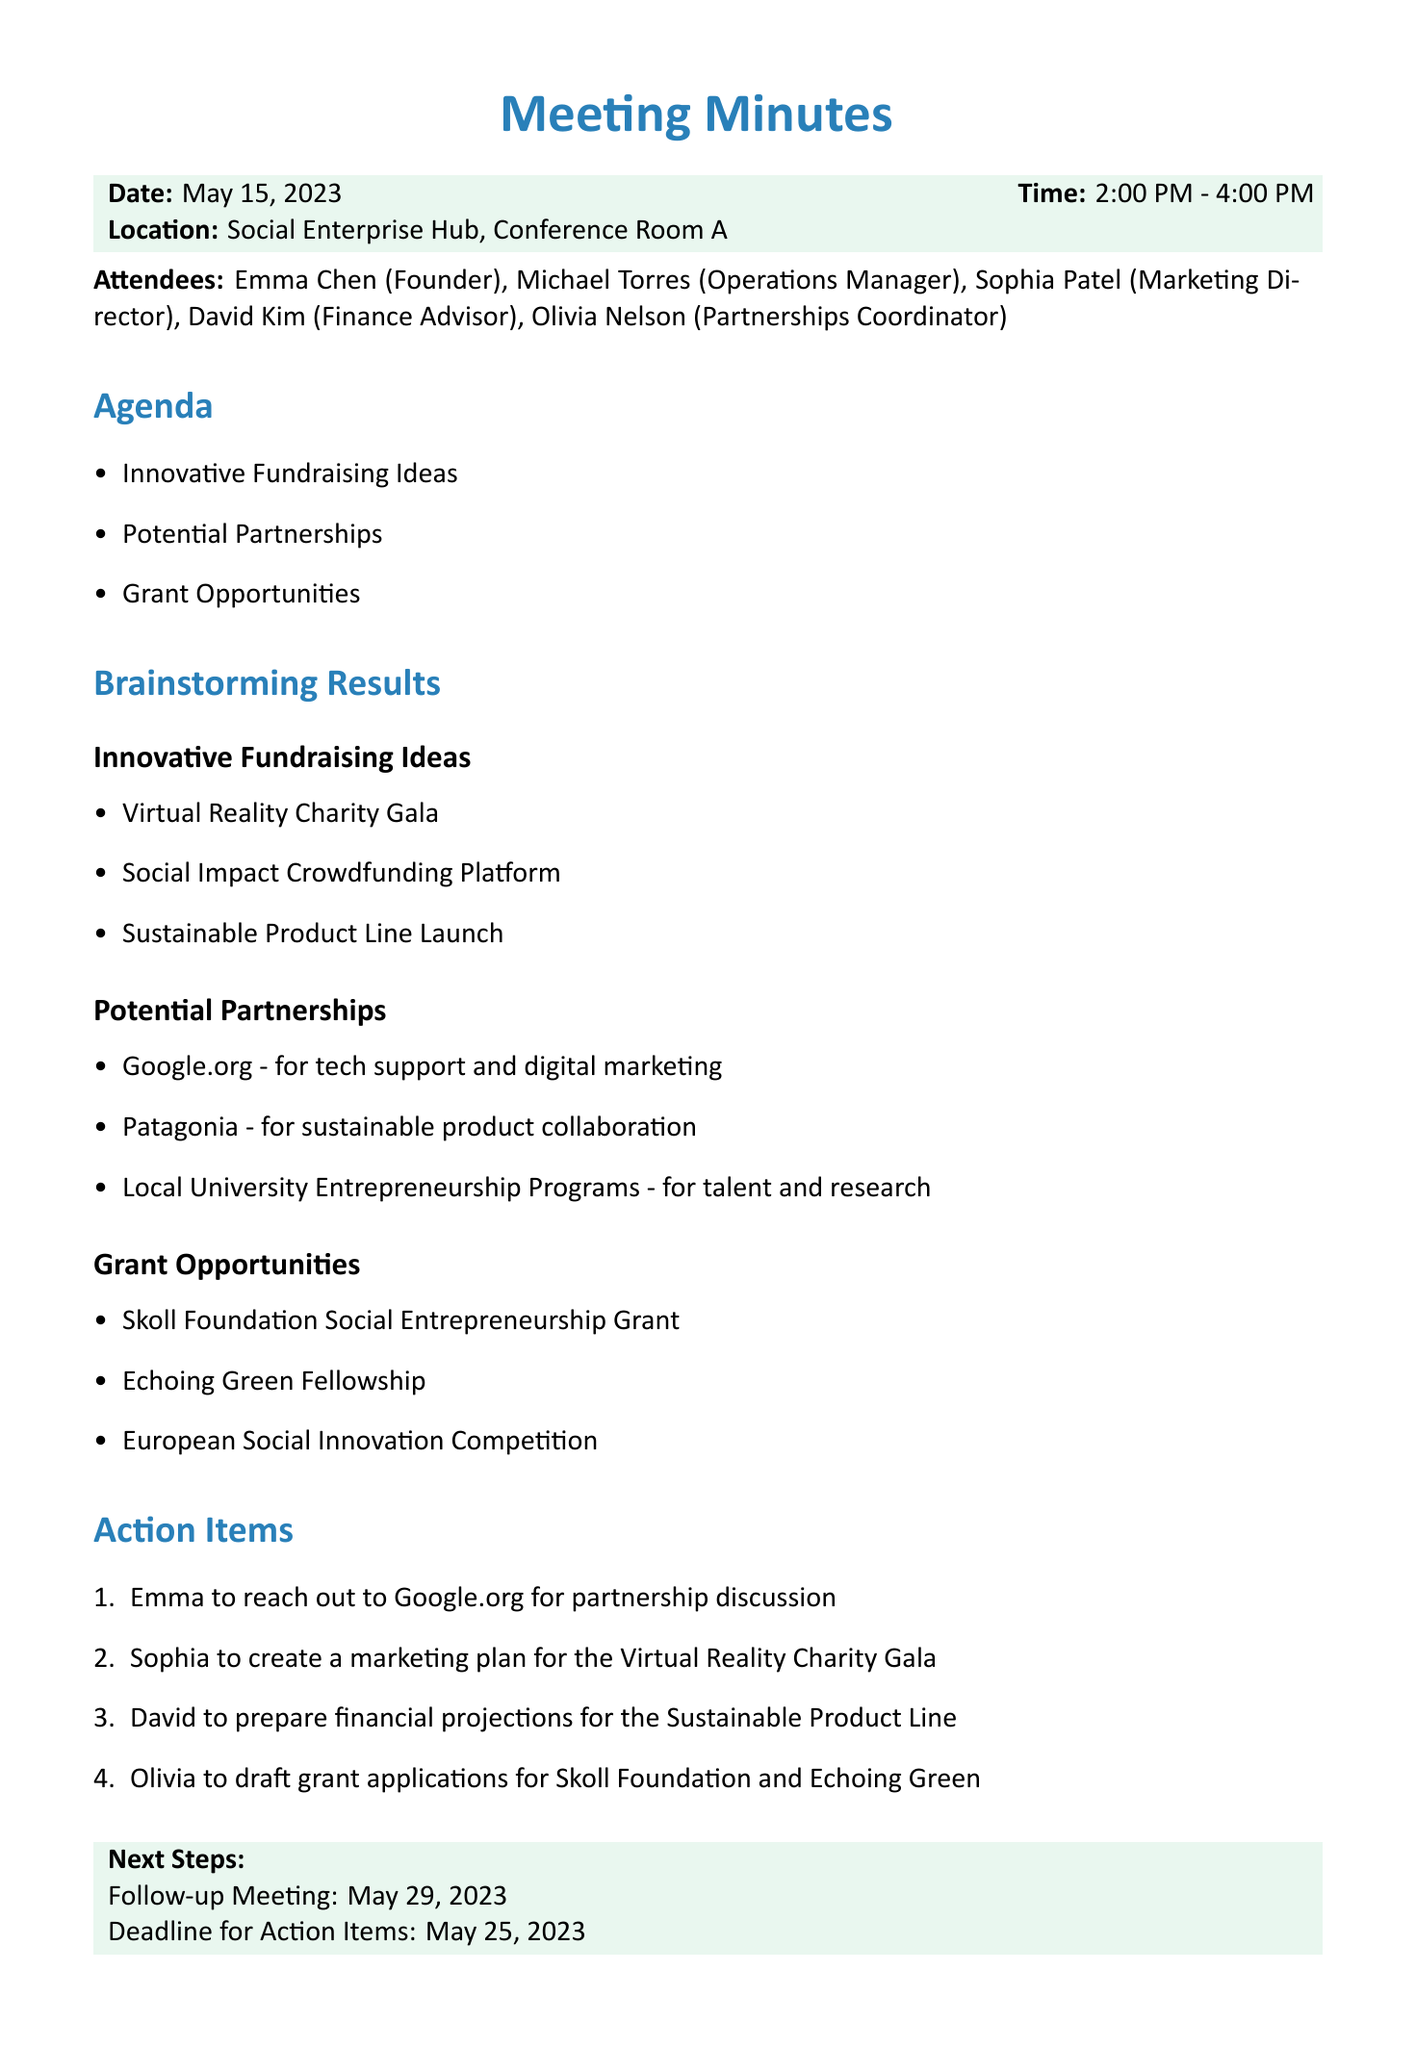What is the date of the meeting? The date of the meeting is explicitly mentioned in the meeting details section.
Answer: May 15, 2023 Who is the Partnerships Coordinator? The attendees section lists the roles and names of all participants in the meeting.
Answer: Olivia Nelson What innovative fundraising idea involves virtual reality? The brainstorming results section specifies various innovative fundraising ideas discussed during the meeting.
Answer: Virtual Reality Charity Gala Which organization is suggested for a partnership focused on sustainable product collaboration? The potential partnerships subsection lists suggested organizations with their respective focus areas.
Answer: Patagonia What is the deadline for action items? The next steps section includes the deadline for action items specified during the meeting.
Answer: May 25, 2023 How many attendees were present at the meeting? The meeting details section provides information on the number of attendees by listing their names.
Answer: Five Which grant opportunity is focused on social entrepreneurship? The grant opportunities section lists several grants with a focus on social entrepreneurship.
Answer: Skoll Foundation Social Entrepreneurship Grant Who will create a marketing plan for the Virtual Reality Charity Gala? The action items section indicates specific tasks assigned to individuals.
Answer: Sophia What is the follow-up meeting date? The next steps section mentions the date for the follow-up meeting.
Answer: May 29, 2023 